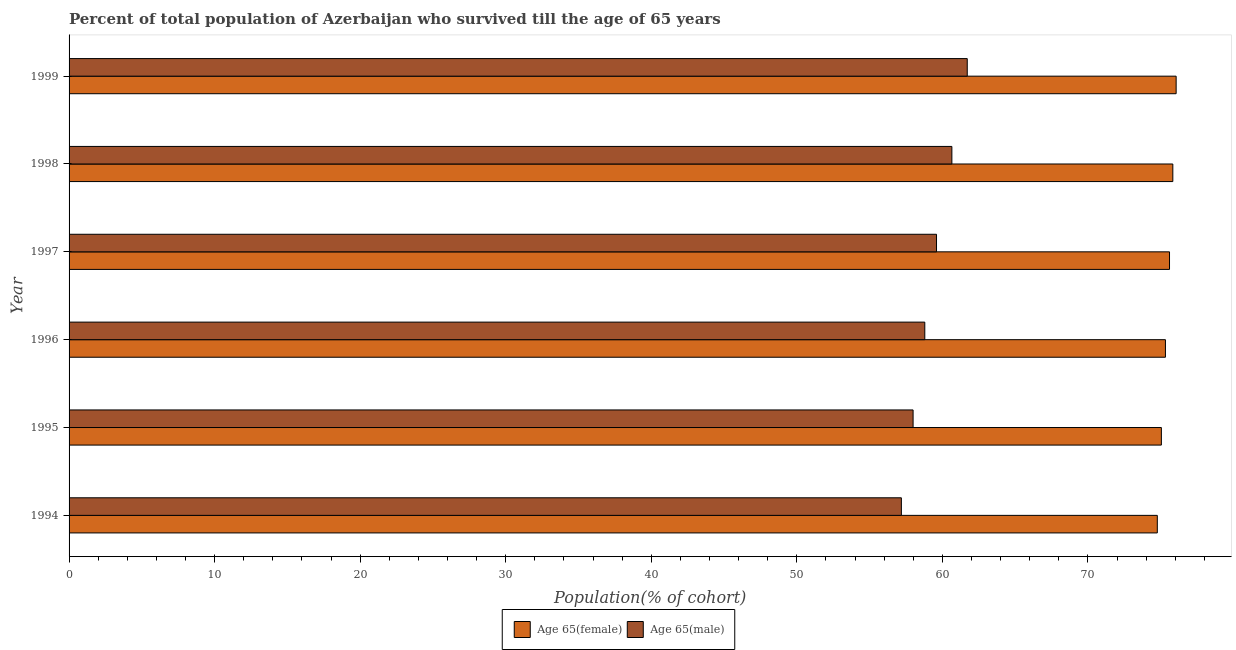How many different coloured bars are there?
Offer a terse response. 2. Are the number of bars on each tick of the Y-axis equal?
Offer a very short reply. Yes. How many bars are there on the 1st tick from the top?
Offer a very short reply. 2. How many bars are there on the 2nd tick from the bottom?
Offer a terse response. 2. What is the label of the 1st group of bars from the top?
Ensure brevity in your answer.  1999. What is the percentage of female population who survived till age of 65 in 1995?
Your answer should be very brief. 75.05. Across all years, what is the maximum percentage of male population who survived till age of 65?
Your answer should be very brief. 61.71. Across all years, what is the minimum percentage of male population who survived till age of 65?
Make the answer very short. 57.18. In which year was the percentage of female population who survived till age of 65 maximum?
Ensure brevity in your answer.  1999. What is the total percentage of female population who survived till age of 65 in the graph?
Provide a succinct answer. 452.64. What is the difference between the percentage of male population who survived till age of 65 in 1997 and that in 1999?
Your response must be concise. -2.11. What is the difference between the percentage of female population who survived till age of 65 in 1999 and the percentage of male population who survived till age of 65 in 1996?
Offer a terse response. 17.27. What is the average percentage of female population who survived till age of 65 per year?
Offer a very short reply. 75.44. In the year 1995, what is the difference between the percentage of male population who survived till age of 65 and percentage of female population who survived till age of 65?
Give a very brief answer. -17.06. What is the ratio of the percentage of male population who survived till age of 65 in 1996 to that in 1997?
Ensure brevity in your answer.  0.99. Is the difference between the percentage of male population who survived till age of 65 in 1994 and 1995 greater than the difference between the percentage of female population who survived till age of 65 in 1994 and 1995?
Provide a succinct answer. No. What is the difference between the highest and the second highest percentage of male population who survived till age of 65?
Offer a terse response. 1.06. What is the difference between the highest and the lowest percentage of male population who survived till age of 65?
Provide a short and direct response. 4.53. Is the sum of the percentage of male population who survived till age of 65 in 1998 and 1999 greater than the maximum percentage of female population who survived till age of 65 across all years?
Provide a succinct answer. Yes. What does the 2nd bar from the top in 1997 represents?
Your answer should be compact. Age 65(female). What does the 1st bar from the bottom in 1994 represents?
Keep it short and to the point. Age 65(female). How many bars are there?
Ensure brevity in your answer.  12. Are all the bars in the graph horizontal?
Your response must be concise. Yes. How many years are there in the graph?
Your answer should be very brief. 6. What is the difference between two consecutive major ticks on the X-axis?
Keep it short and to the point. 10. Are the values on the major ticks of X-axis written in scientific E-notation?
Keep it short and to the point. No. What is the title of the graph?
Your answer should be compact. Percent of total population of Azerbaijan who survived till the age of 65 years. What is the label or title of the X-axis?
Give a very brief answer. Population(% of cohort). What is the label or title of the Y-axis?
Your answer should be compact. Year. What is the Population(% of cohort) in Age 65(female) in 1994?
Offer a terse response. 74.77. What is the Population(% of cohort) in Age 65(male) in 1994?
Your answer should be very brief. 57.18. What is the Population(% of cohort) in Age 65(female) in 1995?
Provide a short and direct response. 75.05. What is the Population(% of cohort) in Age 65(male) in 1995?
Make the answer very short. 57.99. What is the Population(% of cohort) of Age 65(female) in 1996?
Give a very brief answer. 75.33. What is the Population(% of cohort) in Age 65(male) in 1996?
Provide a short and direct response. 58.79. What is the Population(% of cohort) of Age 65(female) in 1997?
Keep it short and to the point. 75.61. What is the Population(% of cohort) of Age 65(male) in 1997?
Ensure brevity in your answer.  59.6. What is the Population(% of cohort) of Age 65(female) in 1998?
Provide a succinct answer. 75.83. What is the Population(% of cohort) of Age 65(male) in 1998?
Provide a succinct answer. 60.65. What is the Population(% of cohort) of Age 65(female) in 1999?
Your response must be concise. 76.06. What is the Population(% of cohort) in Age 65(male) in 1999?
Provide a succinct answer. 61.71. Across all years, what is the maximum Population(% of cohort) of Age 65(female)?
Give a very brief answer. 76.06. Across all years, what is the maximum Population(% of cohort) of Age 65(male)?
Offer a terse response. 61.71. Across all years, what is the minimum Population(% of cohort) in Age 65(female)?
Provide a short and direct response. 74.77. Across all years, what is the minimum Population(% of cohort) in Age 65(male)?
Ensure brevity in your answer.  57.18. What is the total Population(% of cohort) of Age 65(female) in the graph?
Ensure brevity in your answer.  452.64. What is the total Population(% of cohort) in Age 65(male) in the graph?
Give a very brief answer. 355.92. What is the difference between the Population(% of cohort) of Age 65(female) in 1994 and that in 1995?
Offer a terse response. -0.28. What is the difference between the Population(% of cohort) in Age 65(male) in 1994 and that in 1995?
Provide a short and direct response. -0.8. What is the difference between the Population(% of cohort) of Age 65(female) in 1994 and that in 1996?
Make the answer very short. -0.56. What is the difference between the Population(% of cohort) of Age 65(male) in 1994 and that in 1996?
Offer a terse response. -1.61. What is the difference between the Population(% of cohort) of Age 65(female) in 1994 and that in 1997?
Provide a short and direct response. -0.84. What is the difference between the Population(% of cohort) in Age 65(male) in 1994 and that in 1997?
Offer a very short reply. -2.41. What is the difference between the Population(% of cohort) in Age 65(female) in 1994 and that in 1998?
Offer a very short reply. -1.07. What is the difference between the Population(% of cohort) of Age 65(male) in 1994 and that in 1998?
Offer a very short reply. -3.47. What is the difference between the Population(% of cohort) of Age 65(female) in 1994 and that in 1999?
Make the answer very short. -1.29. What is the difference between the Population(% of cohort) in Age 65(male) in 1994 and that in 1999?
Provide a succinct answer. -4.53. What is the difference between the Population(% of cohort) in Age 65(female) in 1995 and that in 1996?
Keep it short and to the point. -0.28. What is the difference between the Population(% of cohort) in Age 65(male) in 1995 and that in 1996?
Offer a terse response. -0.8. What is the difference between the Population(% of cohort) in Age 65(female) in 1995 and that in 1997?
Ensure brevity in your answer.  -0.56. What is the difference between the Population(% of cohort) of Age 65(male) in 1995 and that in 1997?
Give a very brief answer. -1.61. What is the difference between the Population(% of cohort) in Age 65(female) in 1995 and that in 1998?
Offer a very short reply. -0.79. What is the difference between the Population(% of cohort) in Age 65(male) in 1995 and that in 1998?
Offer a terse response. -2.67. What is the difference between the Population(% of cohort) of Age 65(female) in 1995 and that in 1999?
Make the answer very short. -1.01. What is the difference between the Population(% of cohort) in Age 65(male) in 1995 and that in 1999?
Offer a terse response. -3.72. What is the difference between the Population(% of cohort) of Age 65(female) in 1996 and that in 1997?
Your answer should be very brief. -0.28. What is the difference between the Population(% of cohort) of Age 65(male) in 1996 and that in 1997?
Offer a very short reply. -0.8. What is the difference between the Population(% of cohort) of Age 65(female) in 1996 and that in 1998?
Give a very brief answer. -0.51. What is the difference between the Population(% of cohort) in Age 65(male) in 1996 and that in 1998?
Give a very brief answer. -1.86. What is the difference between the Population(% of cohort) of Age 65(female) in 1996 and that in 1999?
Make the answer very short. -0.73. What is the difference between the Population(% of cohort) of Age 65(male) in 1996 and that in 1999?
Your response must be concise. -2.92. What is the difference between the Population(% of cohort) of Age 65(female) in 1997 and that in 1998?
Offer a very short reply. -0.23. What is the difference between the Population(% of cohort) in Age 65(male) in 1997 and that in 1998?
Your answer should be very brief. -1.06. What is the difference between the Population(% of cohort) in Age 65(female) in 1997 and that in 1999?
Your answer should be compact. -0.46. What is the difference between the Population(% of cohort) in Age 65(male) in 1997 and that in 1999?
Ensure brevity in your answer.  -2.11. What is the difference between the Population(% of cohort) of Age 65(female) in 1998 and that in 1999?
Make the answer very short. -0.23. What is the difference between the Population(% of cohort) in Age 65(male) in 1998 and that in 1999?
Your answer should be compact. -1.06. What is the difference between the Population(% of cohort) in Age 65(female) in 1994 and the Population(% of cohort) in Age 65(male) in 1995?
Keep it short and to the point. 16.78. What is the difference between the Population(% of cohort) of Age 65(female) in 1994 and the Population(% of cohort) of Age 65(male) in 1996?
Your response must be concise. 15.97. What is the difference between the Population(% of cohort) in Age 65(female) in 1994 and the Population(% of cohort) in Age 65(male) in 1997?
Offer a terse response. 15.17. What is the difference between the Population(% of cohort) in Age 65(female) in 1994 and the Population(% of cohort) in Age 65(male) in 1998?
Keep it short and to the point. 14.11. What is the difference between the Population(% of cohort) in Age 65(female) in 1994 and the Population(% of cohort) in Age 65(male) in 1999?
Offer a very short reply. 13.06. What is the difference between the Population(% of cohort) of Age 65(female) in 1995 and the Population(% of cohort) of Age 65(male) in 1996?
Offer a very short reply. 16.25. What is the difference between the Population(% of cohort) of Age 65(female) in 1995 and the Population(% of cohort) of Age 65(male) in 1997?
Keep it short and to the point. 15.45. What is the difference between the Population(% of cohort) of Age 65(female) in 1995 and the Population(% of cohort) of Age 65(male) in 1998?
Offer a terse response. 14.39. What is the difference between the Population(% of cohort) of Age 65(female) in 1995 and the Population(% of cohort) of Age 65(male) in 1999?
Ensure brevity in your answer.  13.34. What is the difference between the Population(% of cohort) in Age 65(female) in 1996 and the Population(% of cohort) in Age 65(male) in 1997?
Provide a short and direct response. 15.73. What is the difference between the Population(% of cohort) in Age 65(female) in 1996 and the Population(% of cohort) in Age 65(male) in 1998?
Your response must be concise. 14.67. What is the difference between the Population(% of cohort) of Age 65(female) in 1996 and the Population(% of cohort) of Age 65(male) in 1999?
Offer a terse response. 13.62. What is the difference between the Population(% of cohort) of Age 65(female) in 1997 and the Population(% of cohort) of Age 65(male) in 1998?
Provide a short and direct response. 14.95. What is the difference between the Population(% of cohort) in Age 65(female) in 1997 and the Population(% of cohort) in Age 65(male) in 1999?
Make the answer very short. 13.9. What is the difference between the Population(% of cohort) of Age 65(female) in 1998 and the Population(% of cohort) of Age 65(male) in 1999?
Your answer should be very brief. 14.12. What is the average Population(% of cohort) in Age 65(female) per year?
Give a very brief answer. 75.44. What is the average Population(% of cohort) in Age 65(male) per year?
Your response must be concise. 59.32. In the year 1994, what is the difference between the Population(% of cohort) in Age 65(female) and Population(% of cohort) in Age 65(male)?
Give a very brief answer. 17.58. In the year 1995, what is the difference between the Population(% of cohort) of Age 65(female) and Population(% of cohort) of Age 65(male)?
Your answer should be very brief. 17.06. In the year 1996, what is the difference between the Population(% of cohort) in Age 65(female) and Population(% of cohort) in Age 65(male)?
Keep it short and to the point. 16.53. In the year 1997, what is the difference between the Population(% of cohort) of Age 65(female) and Population(% of cohort) of Age 65(male)?
Your response must be concise. 16.01. In the year 1998, what is the difference between the Population(% of cohort) of Age 65(female) and Population(% of cohort) of Age 65(male)?
Ensure brevity in your answer.  15.18. In the year 1999, what is the difference between the Population(% of cohort) in Age 65(female) and Population(% of cohort) in Age 65(male)?
Ensure brevity in your answer.  14.35. What is the ratio of the Population(% of cohort) in Age 65(female) in 1994 to that in 1995?
Give a very brief answer. 1. What is the ratio of the Population(% of cohort) of Age 65(male) in 1994 to that in 1995?
Offer a terse response. 0.99. What is the ratio of the Population(% of cohort) in Age 65(female) in 1994 to that in 1996?
Your answer should be very brief. 0.99. What is the ratio of the Population(% of cohort) of Age 65(male) in 1994 to that in 1996?
Your answer should be compact. 0.97. What is the ratio of the Population(% of cohort) in Age 65(female) in 1994 to that in 1997?
Make the answer very short. 0.99. What is the ratio of the Population(% of cohort) of Age 65(male) in 1994 to that in 1997?
Your response must be concise. 0.96. What is the ratio of the Population(% of cohort) in Age 65(female) in 1994 to that in 1998?
Your response must be concise. 0.99. What is the ratio of the Population(% of cohort) in Age 65(male) in 1994 to that in 1998?
Your response must be concise. 0.94. What is the ratio of the Population(% of cohort) of Age 65(male) in 1994 to that in 1999?
Make the answer very short. 0.93. What is the ratio of the Population(% of cohort) in Age 65(male) in 1995 to that in 1996?
Give a very brief answer. 0.99. What is the ratio of the Population(% of cohort) in Age 65(male) in 1995 to that in 1998?
Provide a succinct answer. 0.96. What is the ratio of the Population(% of cohort) in Age 65(female) in 1995 to that in 1999?
Offer a very short reply. 0.99. What is the ratio of the Population(% of cohort) in Age 65(male) in 1995 to that in 1999?
Your answer should be compact. 0.94. What is the ratio of the Population(% of cohort) in Age 65(female) in 1996 to that in 1997?
Provide a short and direct response. 1. What is the ratio of the Population(% of cohort) in Age 65(male) in 1996 to that in 1997?
Your answer should be very brief. 0.99. What is the ratio of the Population(% of cohort) in Age 65(female) in 1996 to that in 1998?
Your answer should be compact. 0.99. What is the ratio of the Population(% of cohort) of Age 65(male) in 1996 to that in 1998?
Keep it short and to the point. 0.97. What is the ratio of the Population(% of cohort) of Age 65(female) in 1996 to that in 1999?
Keep it short and to the point. 0.99. What is the ratio of the Population(% of cohort) of Age 65(male) in 1996 to that in 1999?
Offer a very short reply. 0.95. What is the ratio of the Population(% of cohort) in Age 65(female) in 1997 to that in 1998?
Your answer should be very brief. 1. What is the ratio of the Population(% of cohort) of Age 65(male) in 1997 to that in 1998?
Ensure brevity in your answer.  0.98. What is the ratio of the Population(% of cohort) in Age 65(male) in 1997 to that in 1999?
Make the answer very short. 0.97. What is the ratio of the Population(% of cohort) of Age 65(male) in 1998 to that in 1999?
Provide a short and direct response. 0.98. What is the difference between the highest and the second highest Population(% of cohort) in Age 65(female)?
Make the answer very short. 0.23. What is the difference between the highest and the second highest Population(% of cohort) in Age 65(male)?
Your response must be concise. 1.06. What is the difference between the highest and the lowest Population(% of cohort) in Age 65(female)?
Ensure brevity in your answer.  1.29. What is the difference between the highest and the lowest Population(% of cohort) in Age 65(male)?
Provide a succinct answer. 4.53. 